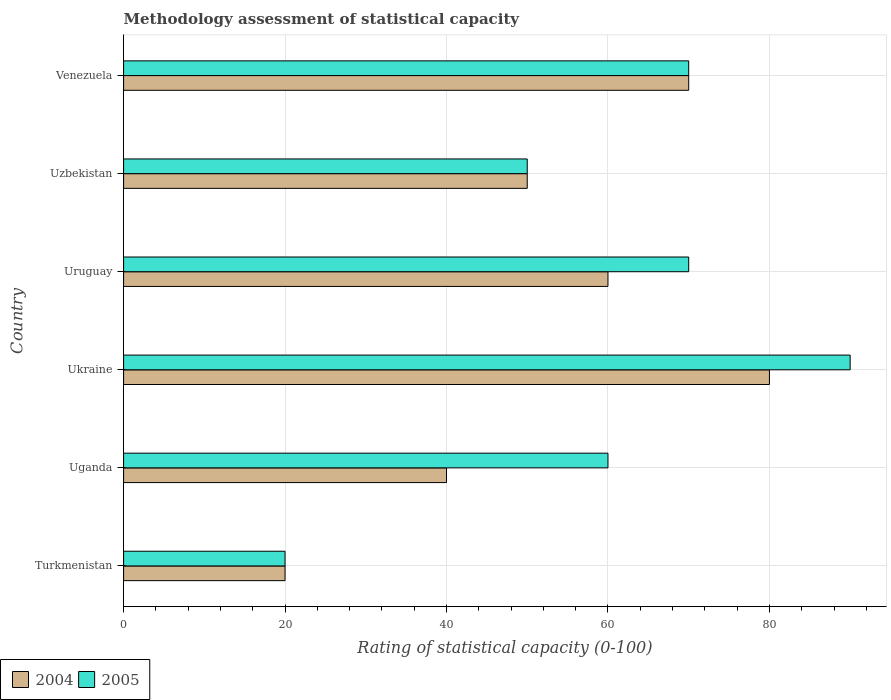Are the number of bars per tick equal to the number of legend labels?
Offer a terse response. Yes. How many bars are there on the 6th tick from the top?
Your answer should be very brief. 2. What is the label of the 3rd group of bars from the top?
Provide a short and direct response. Uruguay. What is the rating of statistical capacity in 2004 in Turkmenistan?
Provide a succinct answer. 20. Across all countries, what is the maximum rating of statistical capacity in 2005?
Offer a terse response. 90. Across all countries, what is the minimum rating of statistical capacity in 2004?
Make the answer very short. 20. In which country was the rating of statistical capacity in 2005 maximum?
Provide a short and direct response. Ukraine. In which country was the rating of statistical capacity in 2004 minimum?
Offer a very short reply. Turkmenistan. What is the total rating of statistical capacity in 2005 in the graph?
Offer a terse response. 360. What is the average rating of statistical capacity in 2004 per country?
Give a very brief answer. 53.33. In how many countries, is the rating of statistical capacity in 2005 greater than 64 ?
Give a very brief answer. 3. What is the ratio of the rating of statistical capacity in 2004 in Ukraine to that in Venezuela?
Make the answer very short. 1.14. What is the difference between the highest and the second highest rating of statistical capacity in 2004?
Your response must be concise. 10. In how many countries, is the rating of statistical capacity in 2005 greater than the average rating of statistical capacity in 2005 taken over all countries?
Provide a short and direct response. 3. What does the 2nd bar from the bottom in Ukraine represents?
Provide a succinct answer. 2005. How many bars are there?
Make the answer very short. 12. Does the graph contain any zero values?
Give a very brief answer. No. Does the graph contain grids?
Ensure brevity in your answer.  Yes. Where does the legend appear in the graph?
Keep it short and to the point. Bottom left. What is the title of the graph?
Provide a short and direct response. Methodology assessment of statistical capacity. What is the label or title of the X-axis?
Ensure brevity in your answer.  Rating of statistical capacity (0-100). What is the Rating of statistical capacity (0-100) in 2004 in Turkmenistan?
Your response must be concise. 20. What is the Rating of statistical capacity (0-100) of 2005 in Turkmenistan?
Your answer should be compact. 20. What is the Rating of statistical capacity (0-100) of 2004 in Uganda?
Provide a succinct answer. 40. What is the Rating of statistical capacity (0-100) in 2004 in Ukraine?
Offer a very short reply. 80. What is the Rating of statistical capacity (0-100) in 2004 in Uzbekistan?
Give a very brief answer. 50. What is the Rating of statistical capacity (0-100) in 2004 in Venezuela?
Ensure brevity in your answer.  70. What is the Rating of statistical capacity (0-100) in 2005 in Venezuela?
Offer a terse response. 70. Across all countries, what is the maximum Rating of statistical capacity (0-100) in 2004?
Ensure brevity in your answer.  80. Across all countries, what is the maximum Rating of statistical capacity (0-100) of 2005?
Make the answer very short. 90. Across all countries, what is the minimum Rating of statistical capacity (0-100) of 2005?
Your answer should be very brief. 20. What is the total Rating of statistical capacity (0-100) of 2004 in the graph?
Your answer should be compact. 320. What is the total Rating of statistical capacity (0-100) of 2005 in the graph?
Keep it short and to the point. 360. What is the difference between the Rating of statistical capacity (0-100) of 2005 in Turkmenistan and that in Uganda?
Keep it short and to the point. -40. What is the difference between the Rating of statistical capacity (0-100) in 2004 in Turkmenistan and that in Ukraine?
Make the answer very short. -60. What is the difference between the Rating of statistical capacity (0-100) of 2005 in Turkmenistan and that in Ukraine?
Make the answer very short. -70. What is the difference between the Rating of statistical capacity (0-100) in 2005 in Turkmenistan and that in Uruguay?
Offer a very short reply. -50. What is the difference between the Rating of statistical capacity (0-100) of 2004 in Uganda and that in Uruguay?
Ensure brevity in your answer.  -20. What is the difference between the Rating of statistical capacity (0-100) of 2004 in Ukraine and that in Uruguay?
Make the answer very short. 20. What is the difference between the Rating of statistical capacity (0-100) in 2004 in Ukraine and that in Venezuela?
Your answer should be compact. 10. What is the difference between the Rating of statistical capacity (0-100) in 2004 in Uruguay and that in Venezuela?
Your response must be concise. -10. What is the difference between the Rating of statistical capacity (0-100) of 2005 in Uruguay and that in Venezuela?
Your answer should be very brief. 0. What is the difference between the Rating of statistical capacity (0-100) in 2004 in Turkmenistan and the Rating of statistical capacity (0-100) in 2005 in Ukraine?
Provide a succinct answer. -70. What is the difference between the Rating of statistical capacity (0-100) in 2004 in Turkmenistan and the Rating of statistical capacity (0-100) in 2005 in Uruguay?
Offer a terse response. -50. What is the difference between the Rating of statistical capacity (0-100) of 2004 in Turkmenistan and the Rating of statistical capacity (0-100) of 2005 in Uzbekistan?
Keep it short and to the point. -30. What is the difference between the Rating of statistical capacity (0-100) in 2004 in Turkmenistan and the Rating of statistical capacity (0-100) in 2005 in Venezuela?
Make the answer very short. -50. What is the difference between the Rating of statistical capacity (0-100) in 2004 in Uganda and the Rating of statistical capacity (0-100) in 2005 in Uruguay?
Give a very brief answer. -30. What is the difference between the Rating of statistical capacity (0-100) of 2004 in Uganda and the Rating of statistical capacity (0-100) of 2005 in Uzbekistan?
Keep it short and to the point. -10. What is the difference between the Rating of statistical capacity (0-100) of 2004 in Uganda and the Rating of statistical capacity (0-100) of 2005 in Venezuela?
Make the answer very short. -30. What is the difference between the Rating of statistical capacity (0-100) in 2004 in Ukraine and the Rating of statistical capacity (0-100) in 2005 in Uruguay?
Your answer should be compact. 10. What is the difference between the Rating of statistical capacity (0-100) of 2004 in Ukraine and the Rating of statistical capacity (0-100) of 2005 in Uzbekistan?
Offer a terse response. 30. What is the difference between the Rating of statistical capacity (0-100) in 2004 in Ukraine and the Rating of statistical capacity (0-100) in 2005 in Venezuela?
Provide a succinct answer. 10. What is the difference between the Rating of statistical capacity (0-100) of 2004 in Uruguay and the Rating of statistical capacity (0-100) of 2005 in Uzbekistan?
Provide a short and direct response. 10. What is the difference between the Rating of statistical capacity (0-100) of 2004 in Uruguay and the Rating of statistical capacity (0-100) of 2005 in Venezuela?
Keep it short and to the point. -10. What is the average Rating of statistical capacity (0-100) in 2004 per country?
Make the answer very short. 53.33. What is the average Rating of statistical capacity (0-100) of 2005 per country?
Keep it short and to the point. 60. What is the difference between the Rating of statistical capacity (0-100) in 2004 and Rating of statistical capacity (0-100) in 2005 in Ukraine?
Offer a terse response. -10. What is the ratio of the Rating of statistical capacity (0-100) in 2004 in Turkmenistan to that in Uganda?
Make the answer very short. 0.5. What is the ratio of the Rating of statistical capacity (0-100) in 2005 in Turkmenistan to that in Ukraine?
Your answer should be compact. 0.22. What is the ratio of the Rating of statistical capacity (0-100) in 2004 in Turkmenistan to that in Uruguay?
Offer a terse response. 0.33. What is the ratio of the Rating of statistical capacity (0-100) of 2005 in Turkmenistan to that in Uruguay?
Make the answer very short. 0.29. What is the ratio of the Rating of statistical capacity (0-100) in 2004 in Turkmenistan to that in Uzbekistan?
Provide a short and direct response. 0.4. What is the ratio of the Rating of statistical capacity (0-100) in 2005 in Turkmenistan to that in Uzbekistan?
Make the answer very short. 0.4. What is the ratio of the Rating of statistical capacity (0-100) in 2004 in Turkmenistan to that in Venezuela?
Give a very brief answer. 0.29. What is the ratio of the Rating of statistical capacity (0-100) of 2005 in Turkmenistan to that in Venezuela?
Your response must be concise. 0.29. What is the ratio of the Rating of statistical capacity (0-100) in 2005 in Uganda to that in Ukraine?
Your answer should be compact. 0.67. What is the ratio of the Rating of statistical capacity (0-100) in 2004 in Uganda to that in Uruguay?
Your answer should be compact. 0.67. What is the ratio of the Rating of statistical capacity (0-100) in 2004 in Uganda to that in Uzbekistan?
Make the answer very short. 0.8. What is the ratio of the Rating of statistical capacity (0-100) of 2005 in Uganda to that in Uzbekistan?
Provide a short and direct response. 1.2. What is the ratio of the Rating of statistical capacity (0-100) in 2004 in Uganda to that in Venezuela?
Give a very brief answer. 0.57. What is the ratio of the Rating of statistical capacity (0-100) in 2004 in Ukraine to that in Uruguay?
Ensure brevity in your answer.  1.33. What is the ratio of the Rating of statistical capacity (0-100) in 2005 in Ukraine to that in Uzbekistan?
Offer a terse response. 1.8. What is the ratio of the Rating of statistical capacity (0-100) in 2005 in Uruguay to that in Uzbekistan?
Give a very brief answer. 1.4. What is the ratio of the Rating of statistical capacity (0-100) of 2004 in Uzbekistan to that in Venezuela?
Provide a succinct answer. 0.71. What is the difference between the highest and the second highest Rating of statistical capacity (0-100) of 2004?
Ensure brevity in your answer.  10. What is the difference between the highest and the lowest Rating of statistical capacity (0-100) in 2005?
Your answer should be compact. 70. 